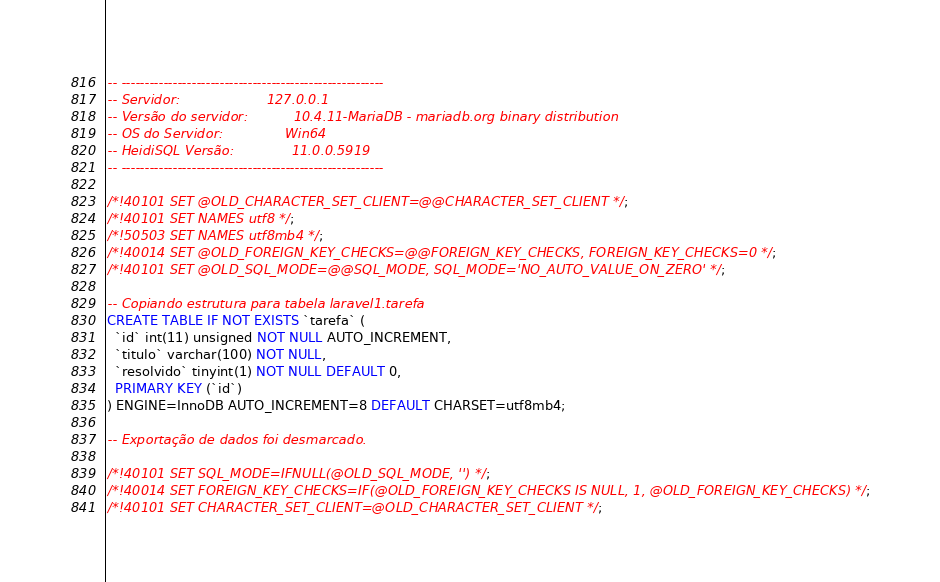<code> <loc_0><loc_0><loc_500><loc_500><_SQL_>-- --------------------------------------------------------
-- Servidor:                     127.0.0.1
-- Versão do servidor:           10.4.11-MariaDB - mariadb.org binary distribution
-- OS do Servidor:               Win64
-- HeidiSQL Versão:              11.0.0.5919
-- --------------------------------------------------------

/*!40101 SET @OLD_CHARACTER_SET_CLIENT=@@CHARACTER_SET_CLIENT */;
/*!40101 SET NAMES utf8 */;
/*!50503 SET NAMES utf8mb4 */;
/*!40014 SET @OLD_FOREIGN_KEY_CHECKS=@@FOREIGN_KEY_CHECKS, FOREIGN_KEY_CHECKS=0 */;
/*!40101 SET @OLD_SQL_MODE=@@SQL_MODE, SQL_MODE='NO_AUTO_VALUE_ON_ZERO' */;

-- Copiando estrutura para tabela laravel1.tarefa
CREATE TABLE IF NOT EXISTS `tarefa` (
  `id` int(11) unsigned NOT NULL AUTO_INCREMENT,
  `titulo` varchar(100) NOT NULL,
  `resolvido` tinyint(1) NOT NULL DEFAULT 0,
  PRIMARY KEY (`id`)
) ENGINE=InnoDB AUTO_INCREMENT=8 DEFAULT CHARSET=utf8mb4;

-- Exportação de dados foi desmarcado.

/*!40101 SET SQL_MODE=IFNULL(@OLD_SQL_MODE, '') */;
/*!40014 SET FOREIGN_KEY_CHECKS=IF(@OLD_FOREIGN_KEY_CHECKS IS NULL, 1, @OLD_FOREIGN_KEY_CHECKS) */;
/*!40101 SET CHARACTER_SET_CLIENT=@OLD_CHARACTER_SET_CLIENT */;
</code> 